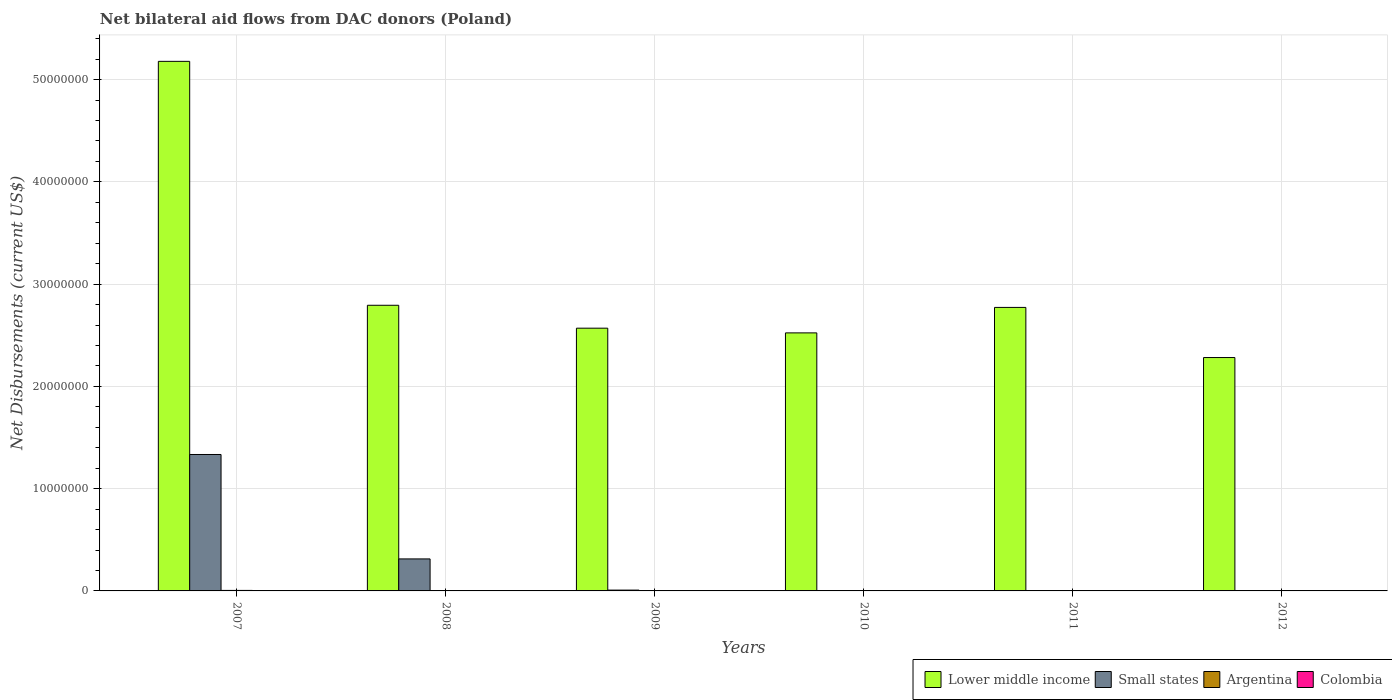How many groups of bars are there?
Offer a terse response. 6. Are the number of bars per tick equal to the number of legend labels?
Offer a terse response. No. Are the number of bars on each tick of the X-axis equal?
Provide a short and direct response. No. How many bars are there on the 1st tick from the right?
Your answer should be very brief. 3. What is the net bilateral aid flows in Small states in 2008?
Your response must be concise. 3.13e+06. Across all years, what is the maximum net bilateral aid flows in Small states?
Provide a short and direct response. 1.33e+07. Across all years, what is the minimum net bilateral aid flows in Argentina?
Keep it short and to the point. 10000. In which year was the net bilateral aid flows in Small states maximum?
Provide a succinct answer. 2007. What is the total net bilateral aid flows in Colombia in the graph?
Keep it short and to the point. 1.20e+05. What is the difference between the net bilateral aid flows in Small states in 2007 and that in 2009?
Provide a short and direct response. 1.33e+07. What is the difference between the net bilateral aid flows in Colombia in 2011 and the net bilateral aid flows in Small states in 2008?
Your response must be concise. -3.09e+06. What is the average net bilateral aid flows in Small states per year?
Make the answer very short. 2.76e+06. In the year 2009, what is the difference between the net bilateral aid flows in Colombia and net bilateral aid flows in Small states?
Offer a very short reply. -6.00e+04. What is the ratio of the net bilateral aid flows in Argentina in 2007 to that in 2009?
Provide a succinct answer. 2.5. What is the difference between the highest and the lowest net bilateral aid flows in Argentina?
Offer a terse response. 4.00e+04. Is it the case that in every year, the sum of the net bilateral aid flows in Argentina and net bilateral aid flows in Colombia is greater than the sum of net bilateral aid flows in Small states and net bilateral aid flows in Lower middle income?
Your answer should be compact. No. Is it the case that in every year, the sum of the net bilateral aid flows in Colombia and net bilateral aid flows in Argentina is greater than the net bilateral aid flows in Small states?
Make the answer very short. No. Are all the bars in the graph horizontal?
Your response must be concise. No. How many years are there in the graph?
Make the answer very short. 6. What is the difference between two consecutive major ticks on the Y-axis?
Your answer should be compact. 1.00e+07. Are the values on the major ticks of Y-axis written in scientific E-notation?
Your response must be concise. No. Does the graph contain any zero values?
Your answer should be compact. Yes. Does the graph contain grids?
Your response must be concise. Yes. Where does the legend appear in the graph?
Make the answer very short. Bottom right. How are the legend labels stacked?
Your answer should be compact. Horizontal. What is the title of the graph?
Provide a short and direct response. Net bilateral aid flows from DAC donors (Poland). Does "Philippines" appear as one of the legend labels in the graph?
Offer a terse response. No. What is the label or title of the X-axis?
Ensure brevity in your answer.  Years. What is the label or title of the Y-axis?
Your answer should be compact. Net Disbursements (current US$). What is the Net Disbursements (current US$) of Lower middle income in 2007?
Your answer should be very brief. 5.18e+07. What is the Net Disbursements (current US$) in Small states in 2007?
Make the answer very short. 1.33e+07. What is the Net Disbursements (current US$) of Argentina in 2007?
Provide a short and direct response. 5.00e+04. What is the Net Disbursements (current US$) in Lower middle income in 2008?
Ensure brevity in your answer.  2.79e+07. What is the Net Disbursements (current US$) of Small states in 2008?
Make the answer very short. 3.13e+06. What is the Net Disbursements (current US$) of Lower middle income in 2009?
Keep it short and to the point. 2.57e+07. What is the Net Disbursements (current US$) of Small states in 2009?
Ensure brevity in your answer.  8.00e+04. What is the Net Disbursements (current US$) of Colombia in 2009?
Make the answer very short. 2.00e+04. What is the Net Disbursements (current US$) of Lower middle income in 2010?
Your response must be concise. 2.52e+07. What is the Net Disbursements (current US$) of Lower middle income in 2011?
Ensure brevity in your answer.  2.77e+07. What is the Net Disbursements (current US$) in Small states in 2011?
Provide a succinct answer. 0. What is the Net Disbursements (current US$) in Argentina in 2011?
Your response must be concise. 10000. What is the Net Disbursements (current US$) in Lower middle income in 2012?
Your answer should be compact. 2.28e+07. What is the Net Disbursements (current US$) in Small states in 2012?
Ensure brevity in your answer.  0. What is the Net Disbursements (current US$) in Argentina in 2012?
Your response must be concise. 2.00e+04. What is the Net Disbursements (current US$) in Colombia in 2012?
Ensure brevity in your answer.  2.00e+04. Across all years, what is the maximum Net Disbursements (current US$) in Lower middle income?
Give a very brief answer. 5.18e+07. Across all years, what is the maximum Net Disbursements (current US$) in Small states?
Ensure brevity in your answer.  1.33e+07. Across all years, what is the maximum Net Disbursements (current US$) of Argentina?
Your response must be concise. 5.00e+04. Across all years, what is the maximum Net Disbursements (current US$) of Colombia?
Make the answer very short. 4.00e+04. Across all years, what is the minimum Net Disbursements (current US$) of Lower middle income?
Keep it short and to the point. 2.28e+07. Across all years, what is the minimum Net Disbursements (current US$) of Colombia?
Provide a succinct answer. 10000. What is the total Net Disbursements (current US$) in Lower middle income in the graph?
Provide a short and direct response. 1.81e+08. What is the total Net Disbursements (current US$) in Small states in the graph?
Your answer should be compact. 1.66e+07. What is the total Net Disbursements (current US$) of Argentina in the graph?
Give a very brief answer. 1.30e+05. What is the difference between the Net Disbursements (current US$) of Lower middle income in 2007 and that in 2008?
Provide a succinct answer. 2.38e+07. What is the difference between the Net Disbursements (current US$) in Small states in 2007 and that in 2008?
Keep it short and to the point. 1.02e+07. What is the difference between the Net Disbursements (current US$) in Lower middle income in 2007 and that in 2009?
Your response must be concise. 2.61e+07. What is the difference between the Net Disbursements (current US$) of Small states in 2007 and that in 2009?
Offer a very short reply. 1.33e+07. What is the difference between the Net Disbursements (current US$) of Argentina in 2007 and that in 2009?
Your answer should be very brief. 3.00e+04. What is the difference between the Net Disbursements (current US$) in Lower middle income in 2007 and that in 2010?
Offer a terse response. 2.66e+07. What is the difference between the Net Disbursements (current US$) in Colombia in 2007 and that in 2010?
Keep it short and to the point. -10000. What is the difference between the Net Disbursements (current US$) in Lower middle income in 2007 and that in 2011?
Give a very brief answer. 2.41e+07. What is the difference between the Net Disbursements (current US$) of Argentina in 2007 and that in 2011?
Provide a short and direct response. 4.00e+04. What is the difference between the Net Disbursements (current US$) in Lower middle income in 2007 and that in 2012?
Your answer should be compact. 2.90e+07. What is the difference between the Net Disbursements (current US$) in Argentina in 2007 and that in 2012?
Your response must be concise. 3.00e+04. What is the difference between the Net Disbursements (current US$) of Colombia in 2007 and that in 2012?
Provide a short and direct response. -10000. What is the difference between the Net Disbursements (current US$) of Lower middle income in 2008 and that in 2009?
Ensure brevity in your answer.  2.24e+06. What is the difference between the Net Disbursements (current US$) of Small states in 2008 and that in 2009?
Ensure brevity in your answer.  3.05e+06. What is the difference between the Net Disbursements (current US$) in Argentina in 2008 and that in 2009?
Your response must be concise. 0. What is the difference between the Net Disbursements (current US$) of Colombia in 2008 and that in 2009?
Your response must be concise. -10000. What is the difference between the Net Disbursements (current US$) in Lower middle income in 2008 and that in 2010?
Ensure brevity in your answer.  2.70e+06. What is the difference between the Net Disbursements (current US$) in Argentina in 2008 and that in 2010?
Provide a short and direct response. 10000. What is the difference between the Net Disbursements (current US$) of Colombia in 2008 and that in 2010?
Make the answer very short. -10000. What is the difference between the Net Disbursements (current US$) in Lower middle income in 2008 and that in 2012?
Provide a short and direct response. 5.11e+06. What is the difference between the Net Disbursements (current US$) of Colombia in 2008 and that in 2012?
Keep it short and to the point. -10000. What is the difference between the Net Disbursements (current US$) in Lower middle income in 2009 and that in 2010?
Keep it short and to the point. 4.60e+05. What is the difference between the Net Disbursements (current US$) in Argentina in 2009 and that in 2010?
Give a very brief answer. 10000. What is the difference between the Net Disbursements (current US$) in Colombia in 2009 and that in 2010?
Keep it short and to the point. 0. What is the difference between the Net Disbursements (current US$) of Lower middle income in 2009 and that in 2011?
Make the answer very short. -2.03e+06. What is the difference between the Net Disbursements (current US$) of Argentina in 2009 and that in 2011?
Your answer should be very brief. 10000. What is the difference between the Net Disbursements (current US$) of Colombia in 2009 and that in 2011?
Your answer should be compact. -2.00e+04. What is the difference between the Net Disbursements (current US$) of Lower middle income in 2009 and that in 2012?
Give a very brief answer. 2.87e+06. What is the difference between the Net Disbursements (current US$) of Lower middle income in 2010 and that in 2011?
Provide a succinct answer. -2.49e+06. What is the difference between the Net Disbursements (current US$) in Colombia in 2010 and that in 2011?
Offer a very short reply. -2.00e+04. What is the difference between the Net Disbursements (current US$) in Lower middle income in 2010 and that in 2012?
Your answer should be very brief. 2.41e+06. What is the difference between the Net Disbursements (current US$) of Lower middle income in 2011 and that in 2012?
Your answer should be very brief. 4.90e+06. What is the difference between the Net Disbursements (current US$) of Colombia in 2011 and that in 2012?
Offer a very short reply. 2.00e+04. What is the difference between the Net Disbursements (current US$) of Lower middle income in 2007 and the Net Disbursements (current US$) of Small states in 2008?
Ensure brevity in your answer.  4.86e+07. What is the difference between the Net Disbursements (current US$) in Lower middle income in 2007 and the Net Disbursements (current US$) in Argentina in 2008?
Keep it short and to the point. 5.18e+07. What is the difference between the Net Disbursements (current US$) in Lower middle income in 2007 and the Net Disbursements (current US$) in Colombia in 2008?
Ensure brevity in your answer.  5.18e+07. What is the difference between the Net Disbursements (current US$) of Small states in 2007 and the Net Disbursements (current US$) of Argentina in 2008?
Ensure brevity in your answer.  1.33e+07. What is the difference between the Net Disbursements (current US$) of Small states in 2007 and the Net Disbursements (current US$) of Colombia in 2008?
Your answer should be very brief. 1.33e+07. What is the difference between the Net Disbursements (current US$) in Lower middle income in 2007 and the Net Disbursements (current US$) in Small states in 2009?
Offer a very short reply. 5.17e+07. What is the difference between the Net Disbursements (current US$) of Lower middle income in 2007 and the Net Disbursements (current US$) of Argentina in 2009?
Keep it short and to the point. 5.18e+07. What is the difference between the Net Disbursements (current US$) of Lower middle income in 2007 and the Net Disbursements (current US$) of Colombia in 2009?
Your answer should be compact. 5.18e+07. What is the difference between the Net Disbursements (current US$) of Small states in 2007 and the Net Disbursements (current US$) of Argentina in 2009?
Make the answer very short. 1.33e+07. What is the difference between the Net Disbursements (current US$) in Small states in 2007 and the Net Disbursements (current US$) in Colombia in 2009?
Provide a succinct answer. 1.33e+07. What is the difference between the Net Disbursements (current US$) in Argentina in 2007 and the Net Disbursements (current US$) in Colombia in 2009?
Make the answer very short. 3.00e+04. What is the difference between the Net Disbursements (current US$) of Lower middle income in 2007 and the Net Disbursements (current US$) of Argentina in 2010?
Provide a short and direct response. 5.18e+07. What is the difference between the Net Disbursements (current US$) in Lower middle income in 2007 and the Net Disbursements (current US$) in Colombia in 2010?
Keep it short and to the point. 5.18e+07. What is the difference between the Net Disbursements (current US$) in Small states in 2007 and the Net Disbursements (current US$) in Argentina in 2010?
Offer a terse response. 1.33e+07. What is the difference between the Net Disbursements (current US$) of Small states in 2007 and the Net Disbursements (current US$) of Colombia in 2010?
Your answer should be very brief. 1.33e+07. What is the difference between the Net Disbursements (current US$) of Argentina in 2007 and the Net Disbursements (current US$) of Colombia in 2010?
Keep it short and to the point. 3.00e+04. What is the difference between the Net Disbursements (current US$) in Lower middle income in 2007 and the Net Disbursements (current US$) in Argentina in 2011?
Provide a short and direct response. 5.18e+07. What is the difference between the Net Disbursements (current US$) in Lower middle income in 2007 and the Net Disbursements (current US$) in Colombia in 2011?
Offer a terse response. 5.17e+07. What is the difference between the Net Disbursements (current US$) in Small states in 2007 and the Net Disbursements (current US$) in Argentina in 2011?
Make the answer very short. 1.33e+07. What is the difference between the Net Disbursements (current US$) in Small states in 2007 and the Net Disbursements (current US$) in Colombia in 2011?
Make the answer very short. 1.33e+07. What is the difference between the Net Disbursements (current US$) in Lower middle income in 2007 and the Net Disbursements (current US$) in Argentina in 2012?
Make the answer very short. 5.18e+07. What is the difference between the Net Disbursements (current US$) in Lower middle income in 2007 and the Net Disbursements (current US$) in Colombia in 2012?
Give a very brief answer. 5.18e+07. What is the difference between the Net Disbursements (current US$) of Small states in 2007 and the Net Disbursements (current US$) of Argentina in 2012?
Provide a short and direct response. 1.33e+07. What is the difference between the Net Disbursements (current US$) in Small states in 2007 and the Net Disbursements (current US$) in Colombia in 2012?
Provide a short and direct response. 1.33e+07. What is the difference between the Net Disbursements (current US$) of Argentina in 2007 and the Net Disbursements (current US$) of Colombia in 2012?
Give a very brief answer. 3.00e+04. What is the difference between the Net Disbursements (current US$) of Lower middle income in 2008 and the Net Disbursements (current US$) of Small states in 2009?
Provide a short and direct response. 2.78e+07. What is the difference between the Net Disbursements (current US$) of Lower middle income in 2008 and the Net Disbursements (current US$) of Argentina in 2009?
Your response must be concise. 2.79e+07. What is the difference between the Net Disbursements (current US$) of Lower middle income in 2008 and the Net Disbursements (current US$) of Colombia in 2009?
Provide a short and direct response. 2.79e+07. What is the difference between the Net Disbursements (current US$) of Small states in 2008 and the Net Disbursements (current US$) of Argentina in 2009?
Offer a very short reply. 3.11e+06. What is the difference between the Net Disbursements (current US$) of Small states in 2008 and the Net Disbursements (current US$) of Colombia in 2009?
Keep it short and to the point. 3.11e+06. What is the difference between the Net Disbursements (current US$) of Argentina in 2008 and the Net Disbursements (current US$) of Colombia in 2009?
Make the answer very short. 0. What is the difference between the Net Disbursements (current US$) of Lower middle income in 2008 and the Net Disbursements (current US$) of Argentina in 2010?
Provide a short and direct response. 2.79e+07. What is the difference between the Net Disbursements (current US$) of Lower middle income in 2008 and the Net Disbursements (current US$) of Colombia in 2010?
Ensure brevity in your answer.  2.79e+07. What is the difference between the Net Disbursements (current US$) in Small states in 2008 and the Net Disbursements (current US$) in Argentina in 2010?
Provide a short and direct response. 3.12e+06. What is the difference between the Net Disbursements (current US$) of Small states in 2008 and the Net Disbursements (current US$) of Colombia in 2010?
Give a very brief answer. 3.11e+06. What is the difference between the Net Disbursements (current US$) in Argentina in 2008 and the Net Disbursements (current US$) in Colombia in 2010?
Make the answer very short. 0. What is the difference between the Net Disbursements (current US$) in Lower middle income in 2008 and the Net Disbursements (current US$) in Argentina in 2011?
Your answer should be very brief. 2.79e+07. What is the difference between the Net Disbursements (current US$) of Lower middle income in 2008 and the Net Disbursements (current US$) of Colombia in 2011?
Provide a succinct answer. 2.79e+07. What is the difference between the Net Disbursements (current US$) of Small states in 2008 and the Net Disbursements (current US$) of Argentina in 2011?
Your answer should be very brief. 3.12e+06. What is the difference between the Net Disbursements (current US$) in Small states in 2008 and the Net Disbursements (current US$) in Colombia in 2011?
Provide a short and direct response. 3.09e+06. What is the difference between the Net Disbursements (current US$) of Argentina in 2008 and the Net Disbursements (current US$) of Colombia in 2011?
Your response must be concise. -2.00e+04. What is the difference between the Net Disbursements (current US$) in Lower middle income in 2008 and the Net Disbursements (current US$) in Argentina in 2012?
Give a very brief answer. 2.79e+07. What is the difference between the Net Disbursements (current US$) of Lower middle income in 2008 and the Net Disbursements (current US$) of Colombia in 2012?
Provide a short and direct response. 2.79e+07. What is the difference between the Net Disbursements (current US$) of Small states in 2008 and the Net Disbursements (current US$) of Argentina in 2012?
Offer a very short reply. 3.11e+06. What is the difference between the Net Disbursements (current US$) in Small states in 2008 and the Net Disbursements (current US$) in Colombia in 2012?
Your answer should be very brief. 3.11e+06. What is the difference between the Net Disbursements (current US$) of Lower middle income in 2009 and the Net Disbursements (current US$) of Argentina in 2010?
Make the answer very short. 2.57e+07. What is the difference between the Net Disbursements (current US$) of Lower middle income in 2009 and the Net Disbursements (current US$) of Colombia in 2010?
Provide a short and direct response. 2.57e+07. What is the difference between the Net Disbursements (current US$) in Small states in 2009 and the Net Disbursements (current US$) in Colombia in 2010?
Your answer should be very brief. 6.00e+04. What is the difference between the Net Disbursements (current US$) of Lower middle income in 2009 and the Net Disbursements (current US$) of Argentina in 2011?
Provide a short and direct response. 2.57e+07. What is the difference between the Net Disbursements (current US$) of Lower middle income in 2009 and the Net Disbursements (current US$) of Colombia in 2011?
Provide a short and direct response. 2.56e+07. What is the difference between the Net Disbursements (current US$) of Small states in 2009 and the Net Disbursements (current US$) of Colombia in 2011?
Give a very brief answer. 4.00e+04. What is the difference between the Net Disbursements (current US$) of Argentina in 2009 and the Net Disbursements (current US$) of Colombia in 2011?
Make the answer very short. -2.00e+04. What is the difference between the Net Disbursements (current US$) of Lower middle income in 2009 and the Net Disbursements (current US$) of Argentina in 2012?
Your answer should be very brief. 2.57e+07. What is the difference between the Net Disbursements (current US$) of Lower middle income in 2009 and the Net Disbursements (current US$) of Colombia in 2012?
Offer a very short reply. 2.57e+07. What is the difference between the Net Disbursements (current US$) of Argentina in 2009 and the Net Disbursements (current US$) of Colombia in 2012?
Your answer should be very brief. 0. What is the difference between the Net Disbursements (current US$) of Lower middle income in 2010 and the Net Disbursements (current US$) of Argentina in 2011?
Your answer should be very brief. 2.52e+07. What is the difference between the Net Disbursements (current US$) in Lower middle income in 2010 and the Net Disbursements (current US$) in Colombia in 2011?
Provide a short and direct response. 2.52e+07. What is the difference between the Net Disbursements (current US$) of Lower middle income in 2010 and the Net Disbursements (current US$) of Argentina in 2012?
Keep it short and to the point. 2.52e+07. What is the difference between the Net Disbursements (current US$) of Lower middle income in 2010 and the Net Disbursements (current US$) of Colombia in 2012?
Your response must be concise. 2.52e+07. What is the difference between the Net Disbursements (current US$) in Argentina in 2010 and the Net Disbursements (current US$) in Colombia in 2012?
Keep it short and to the point. -10000. What is the difference between the Net Disbursements (current US$) of Lower middle income in 2011 and the Net Disbursements (current US$) of Argentina in 2012?
Provide a succinct answer. 2.77e+07. What is the difference between the Net Disbursements (current US$) of Lower middle income in 2011 and the Net Disbursements (current US$) of Colombia in 2012?
Keep it short and to the point. 2.77e+07. What is the difference between the Net Disbursements (current US$) of Argentina in 2011 and the Net Disbursements (current US$) of Colombia in 2012?
Provide a short and direct response. -10000. What is the average Net Disbursements (current US$) of Lower middle income per year?
Give a very brief answer. 3.02e+07. What is the average Net Disbursements (current US$) in Small states per year?
Make the answer very short. 2.76e+06. What is the average Net Disbursements (current US$) of Argentina per year?
Offer a very short reply. 2.17e+04. In the year 2007, what is the difference between the Net Disbursements (current US$) in Lower middle income and Net Disbursements (current US$) in Small states?
Make the answer very short. 3.84e+07. In the year 2007, what is the difference between the Net Disbursements (current US$) in Lower middle income and Net Disbursements (current US$) in Argentina?
Ensure brevity in your answer.  5.17e+07. In the year 2007, what is the difference between the Net Disbursements (current US$) in Lower middle income and Net Disbursements (current US$) in Colombia?
Make the answer very short. 5.18e+07. In the year 2007, what is the difference between the Net Disbursements (current US$) in Small states and Net Disbursements (current US$) in Argentina?
Offer a very short reply. 1.33e+07. In the year 2007, what is the difference between the Net Disbursements (current US$) of Small states and Net Disbursements (current US$) of Colombia?
Your answer should be very brief. 1.33e+07. In the year 2008, what is the difference between the Net Disbursements (current US$) in Lower middle income and Net Disbursements (current US$) in Small states?
Keep it short and to the point. 2.48e+07. In the year 2008, what is the difference between the Net Disbursements (current US$) of Lower middle income and Net Disbursements (current US$) of Argentina?
Provide a short and direct response. 2.79e+07. In the year 2008, what is the difference between the Net Disbursements (current US$) in Lower middle income and Net Disbursements (current US$) in Colombia?
Ensure brevity in your answer.  2.79e+07. In the year 2008, what is the difference between the Net Disbursements (current US$) of Small states and Net Disbursements (current US$) of Argentina?
Ensure brevity in your answer.  3.11e+06. In the year 2008, what is the difference between the Net Disbursements (current US$) of Small states and Net Disbursements (current US$) of Colombia?
Keep it short and to the point. 3.12e+06. In the year 2008, what is the difference between the Net Disbursements (current US$) of Argentina and Net Disbursements (current US$) of Colombia?
Provide a short and direct response. 10000. In the year 2009, what is the difference between the Net Disbursements (current US$) of Lower middle income and Net Disbursements (current US$) of Small states?
Offer a very short reply. 2.56e+07. In the year 2009, what is the difference between the Net Disbursements (current US$) in Lower middle income and Net Disbursements (current US$) in Argentina?
Your answer should be compact. 2.57e+07. In the year 2009, what is the difference between the Net Disbursements (current US$) in Lower middle income and Net Disbursements (current US$) in Colombia?
Your answer should be very brief. 2.57e+07. In the year 2010, what is the difference between the Net Disbursements (current US$) of Lower middle income and Net Disbursements (current US$) of Argentina?
Provide a short and direct response. 2.52e+07. In the year 2010, what is the difference between the Net Disbursements (current US$) in Lower middle income and Net Disbursements (current US$) in Colombia?
Your answer should be compact. 2.52e+07. In the year 2011, what is the difference between the Net Disbursements (current US$) in Lower middle income and Net Disbursements (current US$) in Argentina?
Make the answer very short. 2.77e+07. In the year 2011, what is the difference between the Net Disbursements (current US$) of Lower middle income and Net Disbursements (current US$) of Colombia?
Make the answer very short. 2.77e+07. In the year 2011, what is the difference between the Net Disbursements (current US$) in Argentina and Net Disbursements (current US$) in Colombia?
Offer a very short reply. -3.00e+04. In the year 2012, what is the difference between the Net Disbursements (current US$) of Lower middle income and Net Disbursements (current US$) of Argentina?
Your response must be concise. 2.28e+07. In the year 2012, what is the difference between the Net Disbursements (current US$) of Lower middle income and Net Disbursements (current US$) of Colombia?
Keep it short and to the point. 2.28e+07. In the year 2012, what is the difference between the Net Disbursements (current US$) of Argentina and Net Disbursements (current US$) of Colombia?
Provide a short and direct response. 0. What is the ratio of the Net Disbursements (current US$) in Lower middle income in 2007 to that in 2008?
Ensure brevity in your answer.  1.85. What is the ratio of the Net Disbursements (current US$) of Small states in 2007 to that in 2008?
Your response must be concise. 4.26. What is the ratio of the Net Disbursements (current US$) of Colombia in 2007 to that in 2008?
Provide a succinct answer. 1. What is the ratio of the Net Disbursements (current US$) in Lower middle income in 2007 to that in 2009?
Offer a very short reply. 2.02. What is the ratio of the Net Disbursements (current US$) of Small states in 2007 to that in 2009?
Your answer should be compact. 166.75. What is the ratio of the Net Disbursements (current US$) in Colombia in 2007 to that in 2009?
Your answer should be very brief. 0.5. What is the ratio of the Net Disbursements (current US$) in Lower middle income in 2007 to that in 2010?
Provide a short and direct response. 2.05. What is the ratio of the Net Disbursements (current US$) of Argentina in 2007 to that in 2010?
Your answer should be compact. 5. What is the ratio of the Net Disbursements (current US$) in Lower middle income in 2007 to that in 2011?
Give a very brief answer. 1.87. What is the ratio of the Net Disbursements (current US$) of Colombia in 2007 to that in 2011?
Ensure brevity in your answer.  0.25. What is the ratio of the Net Disbursements (current US$) in Lower middle income in 2007 to that in 2012?
Your response must be concise. 2.27. What is the ratio of the Net Disbursements (current US$) in Colombia in 2007 to that in 2012?
Provide a short and direct response. 0.5. What is the ratio of the Net Disbursements (current US$) in Lower middle income in 2008 to that in 2009?
Your response must be concise. 1.09. What is the ratio of the Net Disbursements (current US$) of Small states in 2008 to that in 2009?
Provide a short and direct response. 39.12. What is the ratio of the Net Disbursements (current US$) of Colombia in 2008 to that in 2009?
Make the answer very short. 0.5. What is the ratio of the Net Disbursements (current US$) of Lower middle income in 2008 to that in 2010?
Keep it short and to the point. 1.11. What is the ratio of the Net Disbursements (current US$) in Colombia in 2008 to that in 2010?
Give a very brief answer. 0.5. What is the ratio of the Net Disbursements (current US$) of Lower middle income in 2008 to that in 2011?
Ensure brevity in your answer.  1.01. What is the ratio of the Net Disbursements (current US$) in Argentina in 2008 to that in 2011?
Offer a terse response. 2. What is the ratio of the Net Disbursements (current US$) of Lower middle income in 2008 to that in 2012?
Make the answer very short. 1.22. What is the ratio of the Net Disbursements (current US$) in Argentina in 2008 to that in 2012?
Your answer should be very brief. 1. What is the ratio of the Net Disbursements (current US$) in Lower middle income in 2009 to that in 2010?
Provide a short and direct response. 1.02. What is the ratio of the Net Disbursements (current US$) of Argentina in 2009 to that in 2010?
Your response must be concise. 2. What is the ratio of the Net Disbursements (current US$) of Lower middle income in 2009 to that in 2011?
Your answer should be very brief. 0.93. What is the ratio of the Net Disbursements (current US$) of Argentina in 2009 to that in 2011?
Make the answer very short. 2. What is the ratio of the Net Disbursements (current US$) of Lower middle income in 2009 to that in 2012?
Keep it short and to the point. 1.13. What is the ratio of the Net Disbursements (current US$) in Argentina in 2009 to that in 2012?
Provide a short and direct response. 1. What is the ratio of the Net Disbursements (current US$) in Lower middle income in 2010 to that in 2011?
Your response must be concise. 0.91. What is the ratio of the Net Disbursements (current US$) in Lower middle income in 2010 to that in 2012?
Offer a very short reply. 1.11. What is the ratio of the Net Disbursements (current US$) in Argentina in 2010 to that in 2012?
Your answer should be compact. 0.5. What is the ratio of the Net Disbursements (current US$) in Colombia in 2010 to that in 2012?
Provide a short and direct response. 1. What is the ratio of the Net Disbursements (current US$) of Lower middle income in 2011 to that in 2012?
Your answer should be very brief. 1.21. What is the ratio of the Net Disbursements (current US$) in Argentina in 2011 to that in 2012?
Ensure brevity in your answer.  0.5. What is the ratio of the Net Disbursements (current US$) of Colombia in 2011 to that in 2012?
Offer a very short reply. 2. What is the difference between the highest and the second highest Net Disbursements (current US$) of Lower middle income?
Provide a succinct answer. 2.38e+07. What is the difference between the highest and the second highest Net Disbursements (current US$) of Small states?
Provide a succinct answer. 1.02e+07. What is the difference between the highest and the second highest Net Disbursements (current US$) in Argentina?
Offer a terse response. 3.00e+04. What is the difference between the highest and the second highest Net Disbursements (current US$) in Colombia?
Provide a succinct answer. 2.00e+04. What is the difference between the highest and the lowest Net Disbursements (current US$) in Lower middle income?
Your response must be concise. 2.90e+07. What is the difference between the highest and the lowest Net Disbursements (current US$) of Small states?
Make the answer very short. 1.33e+07. What is the difference between the highest and the lowest Net Disbursements (current US$) in Argentina?
Your answer should be very brief. 4.00e+04. 